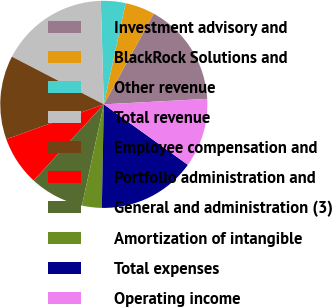Convert chart to OTSL. <chart><loc_0><loc_0><loc_500><loc_500><pie_chart><fcel>Investment advisory and<fcel>BlackRock Solutions and<fcel>Other revenue<fcel>Total revenue<fcel>Employee compensation and<fcel>Portfolio administration and<fcel>General and administration (3)<fcel>Amortization of intangible<fcel>Total expenses<fcel>Operating income<nl><fcel>16.15%<fcel>4.62%<fcel>3.85%<fcel>16.92%<fcel>13.08%<fcel>7.69%<fcel>8.46%<fcel>3.08%<fcel>15.38%<fcel>10.77%<nl></chart> 